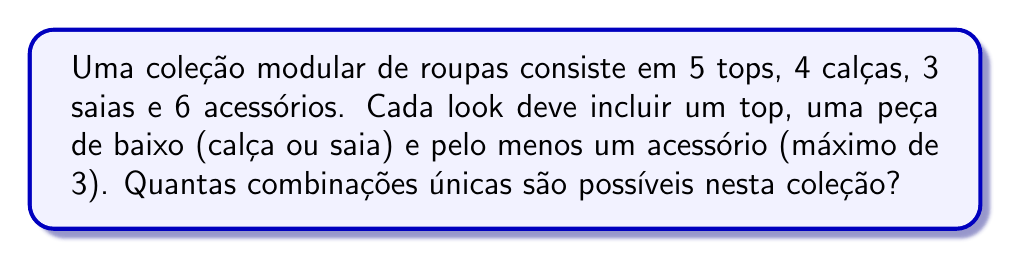Could you help me with this problem? Vamos resolver este problema passo a passo:

1) Primeiro, calculamos o número de combinações de tops e peças de baixo:
   - Tops: 5 opções
   - Peças de baixo: 4 calças + 3 saias = 7 opções
   Total de combinações base: $5 \times 7 = 35$

2) Agora, precisamos considerar as opções de acessórios. Temos 6 acessórios, e podemos usar 1, 2 ou 3 deles:
   - Para 1 acessório: $\binom{6}{1} = 6$ combinações
   - Para 2 acessórios: $\binom{6}{2} = 15$ combinações
   - Para 3 acessórios: $\binom{6}{3} = 20$ combinações

3) O número total de combinações de acessórios é:
   $6 + 15 + 20 = 41$

4) Para cada combinação base de top e peça de baixo, temos 41 opções de acessórios.

5) Portanto, o número total de combinações únicas é:
   $35 \times 41 = 1435$
Answer: 1435 